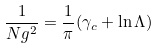<formula> <loc_0><loc_0><loc_500><loc_500>\frac { 1 } { N g ^ { 2 } } = \frac { 1 } { \pi } ( \gamma _ { c } + \ln \Lambda )</formula> 